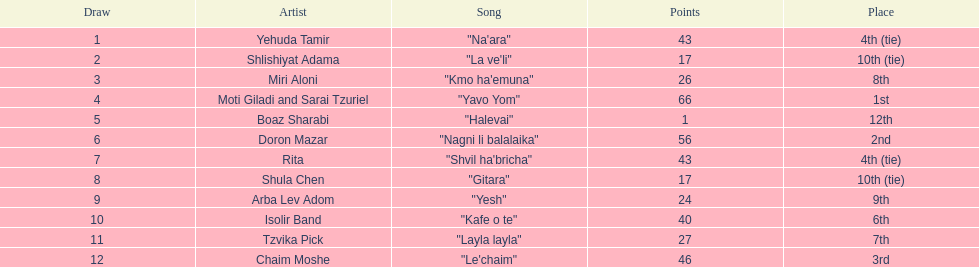What are the number of times an artist earned first place? 1. 